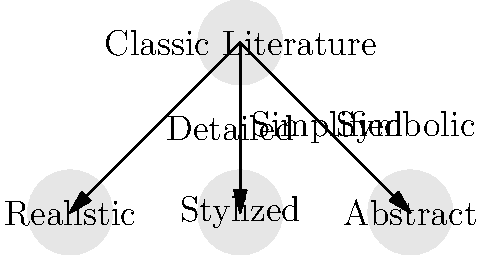In the graphic novel adaptation of classic literature, which artistic style is characterized by simplified representations while maintaining recognizable forms, often used to emphasize key themes or emotions? To answer this question, let's analyze the different artistic styles used in graphic novel adaptations of classic literature:

1. Realistic style:
   - Characterized by detailed and accurate representations
   - Aims to closely mimic real-life appearances
   - Often used to create a sense of authenticity and historical accuracy

2. Stylized style:
   - Involves simplified representations of characters and settings
   - Maintains recognizable forms but reduces unnecessary details
   - Emphasizes key themes or emotions through visual shorthand
   - Allows for greater artistic expression while still being accessible to readers

3. Abstract style:
   - Uses symbolic or non-representational forms
   - May deviate significantly from realistic depictions
   - Often employed to convey complex ideas or emotions
   - Can be challenging for some readers to interpret

Based on the description in the question, which mentions "simplified representations while maintaining recognizable forms," the artistic style being referred to is the stylized approach. This style strikes a balance between realism and abstraction, making it effective for adapting classic literature in a visually engaging way without losing the essence of the original work.
Answer: Stylized 